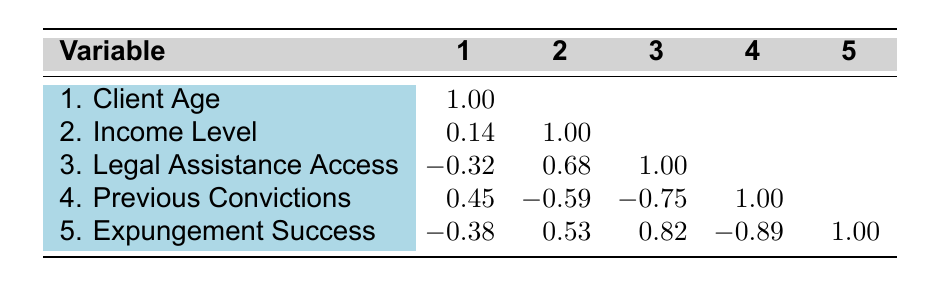What is the correlation between legal assistance access and expungement success? The correlation between legal assistance access and expungement success, as indicated in the table, is 0.82. This means that there is a strong positive relationship: as access to legal assistance increases, the likelihood of expungement success also increases.
Answer: 0.82 How does the correlation between previous convictions and expungement success compare to that of client age and expungement success? The correlation of previous convictions with expungement success is -0.89, indicating a very strong negative relationship; whereas the correlation of client age with expungement success is -0.38, which is weaker. Therefore, previous convictions are more strongly correlated with expungement outcomes than client age is.
Answer: Previous convictions have a stronger correlation What is the correlation between income level and previous convictions? The correlation between income level and previous convictions is -0.59, indicating a moderate negative relationship: as income level increases, the number of previous convictions tends to decrease.
Answer: -0.59 Is it true that a high level of legal assistance access correlates positively with higher income levels? Yes, the correlation between legal assistance access and income level is 0.68, which indicates a positive relationship: individuals with higher levels of legal assistance access tend to have higher income levels.
Answer: Yes What is the average client age for the group that experienced expungement success? The expungement success group includes clients aged 25, 32, 29, 24, and 30. Summing those ages gives 25 + 32 + 29 + 24 + 30 = 170. Dividing by 5 (the number of clients) gives an average age of 34.
Answer: 30 What is the difference in correlation between legal assistance access and previous convictions versus legal assistance access and income level? The correlation between legal assistance access and previous convictions is -0.75, while the correlation between legal assistance access and income level is 0.68. The difference is calculated as follows: 0.68 - (-0.75) = 0.68 + 0.75 = 1.43. This shows that legal assistance access has a stronger negative correlation with previous convictions than it does a positive correlation with income level.
Answer: 1.43 What does the negative correlation of -0.38 between client age and expungement success indicate? A negative correlation of -0.38 suggests that as client age increases, the likelihood of success in expungement decreases, though this is a weak correlation.
Answer: It indicates a weak negative relationship How many clients have high legal assistance access and succeeded in their expungement? The clients with high legal assistance access who succeeded in expungement are the ones aged 25, 29, and 24, totaling 3 clients.
Answer: 3 clients 